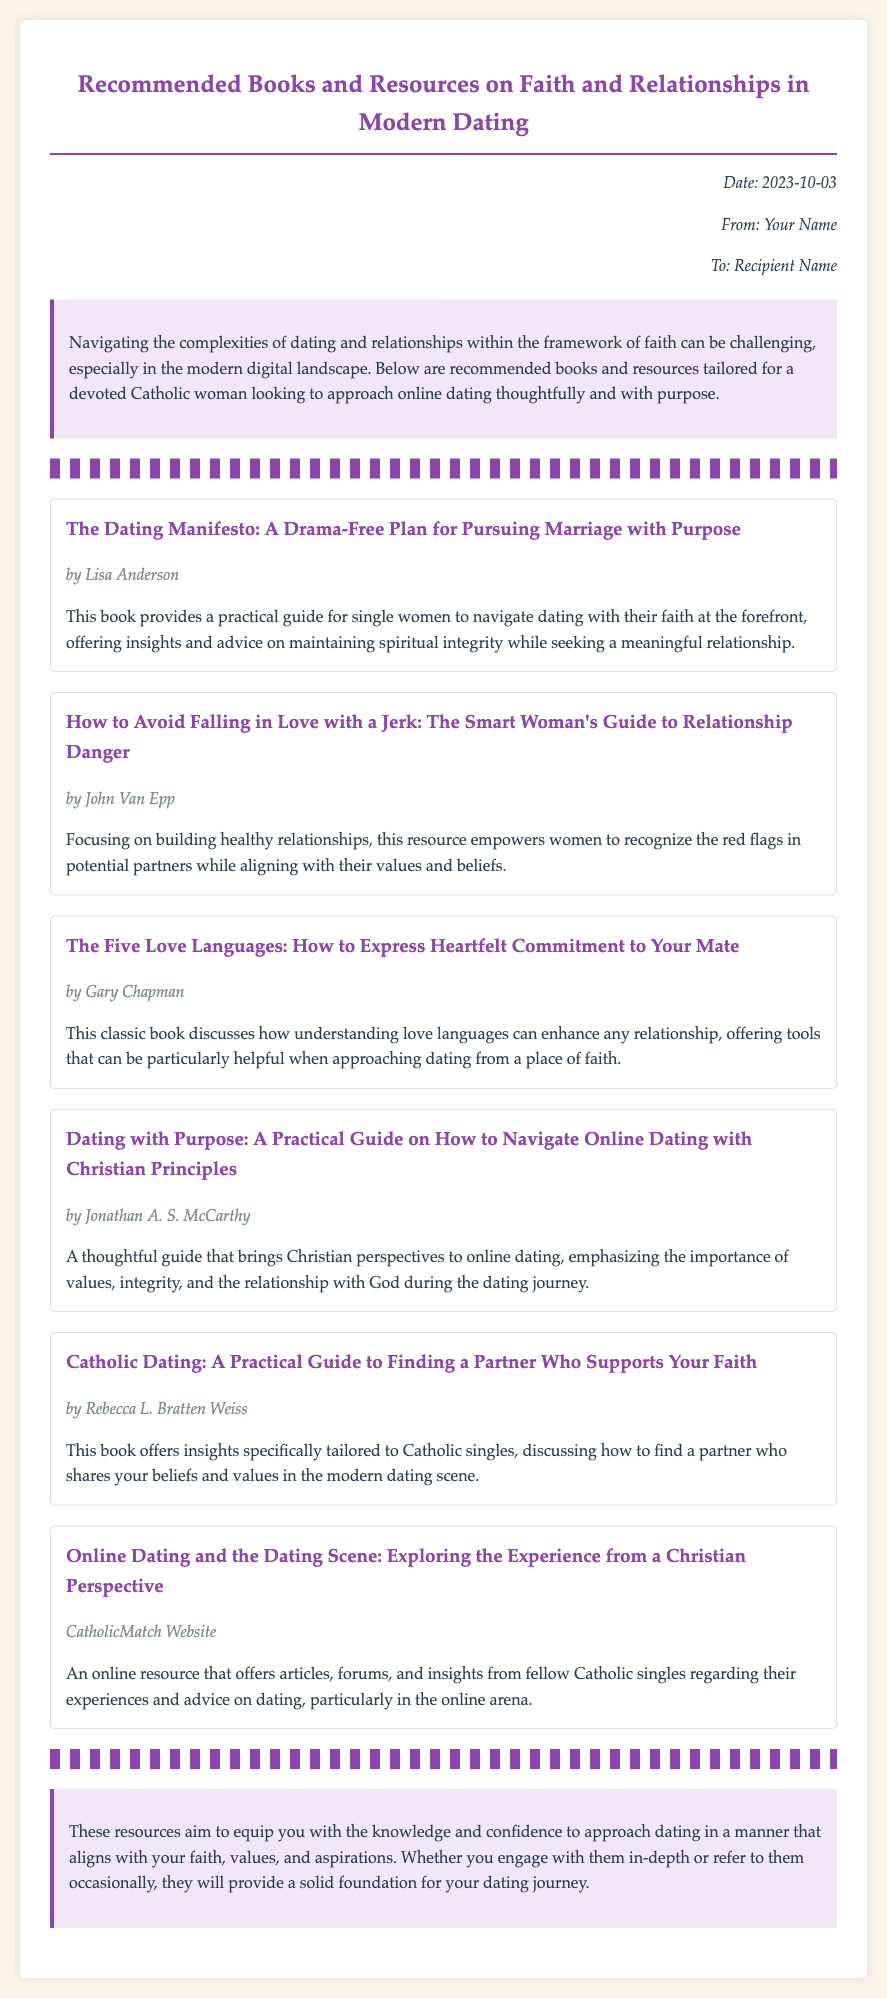what is the title of the document? The title is prominently displayed at the beginning of the memo, indicating the content it covers.
Answer: Recommended Books and Resources on Faith and Relationships in Modern Dating who is the author of "The Dating Manifesto"? The author is mentioned directly below the book title, providing credit for the work.
Answer: Lisa Anderson how many books are listed in the document? The number of books can be counted based on the individual book entries within the memo.
Answer: Six which book focuses on avoiding relationship dangers? This information is found in the title of the book that specifically addresses recognizing red flags in potential partners.
Answer: How to Avoid Falling in Love with a Jerk who is the intended audience of the resources provided? The introduction specifies the target group for whom these recommendations are designed.
Answer: A devoted Catholic woman what is one theme common across the recommended resources? The overarching theme can be inferred from the focus of all the books in the document's content.
Answer: Faith what is the main purpose of the document? The introduction outlines the intention behind providing these recommendations for the audience.
Answer: To equip knowledge and confidence for dating which resource is described as an online platform for Catholic singles? The description highlights the nature of the resource focused on online dating experiences.
Answer: CatholicMatch Website 